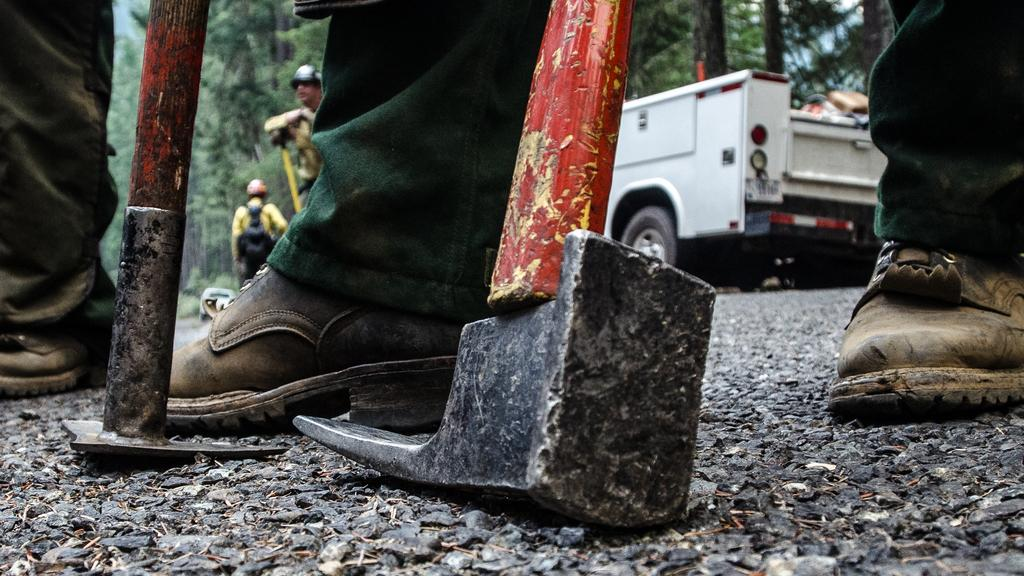How many people are in the image? There are few persons in the image. What are the persons holding in the image? The persons are holding digging tools. What can be seen at the bottom of the image? There is a road at the bottom of the image. What type of vehicle is present in the image? There is a white-colored vehicle in the image. What is visible in the background of the image? There are many trees in the background of the image. What letter is being used to dig in the image? There is no letter being used to dig in the image; the persons are holding digging tools. Can you see any steam coming from the vehicle in the image? There is no steam visible in the image; only a white-colored vehicle is present. 